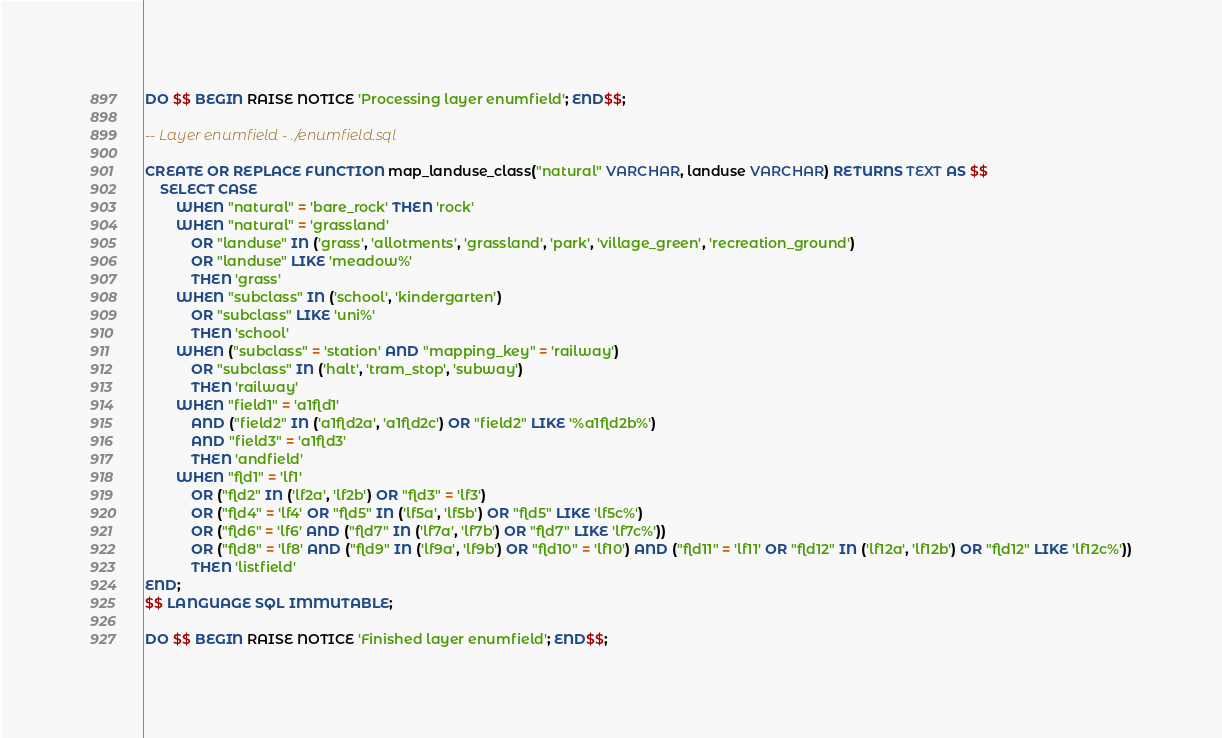Convert code to text. <code><loc_0><loc_0><loc_500><loc_500><_SQL_>DO $$ BEGIN RAISE NOTICE 'Processing layer enumfield'; END$$;

-- Layer enumfield - ./enumfield.sql

CREATE OR REPLACE FUNCTION map_landuse_class("natural" VARCHAR, landuse VARCHAR) RETURNS TEXT AS $$
    SELECT CASE
        WHEN "natural" = 'bare_rock' THEN 'rock'
        WHEN "natural" = 'grassland'
            OR "landuse" IN ('grass', 'allotments', 'grassland', 'park', 'village_green', 'recreation_ground')
            OR "landuse" LIKE 'meadow%'
            THEN 'grass'
        WHEN "subclass" IN ('school', 'kindergarten')
            OR "subclass" LIKE 'uni%'
            THEN 'school'
        WHEN ("subclass" = 'station' AND "mapping_key" = 'railway')
            OR "subclass" IN ('halt', 'tram_stop', 'subway')
            THEN 'railway'
        WHEN "field1" = 'a1fld1'
            AND ("field2" IN ('a1fld2a', 'a1fld2c') OR "field2" LIKE '%a1fld2b%')
            AND "field3" = 'a1fld3'
            THEN 'andfield'
        WHEN "fld1" = 'lf1'
            OR ("fld2" IN ('lf2a', 'lf2b') OR "fld3" = 'lf3')
            OR ("fld4" = 'lf4' OR "fld5" IN ('lf5a', 'lf5b') OR "fld5" LIKE 'lf5c%')
            OR ("fld6" = 'lf6' AND ("fld7" IN ('lf7a', 'lf7b') OR "fld7" LIKE 'lf7c%'))
            OR ("fld8" = 'lf8' AND ("fld9" IN ('lf9a', 'lf9b') OR "fld10" = 'lf10') AND ("fld11" = 'lf11' OR "fld12" IN ('lf12a', 'lf12b') OR "fld12" LIKE 'lf12c%'))
            THEN 'listfield'
END;
$$ LANGUAGE SQL IMMUTABLE;

DO $$ BEGIN RAISE NOTICE 'Finished layer enumfield'; END$$;
</code> 